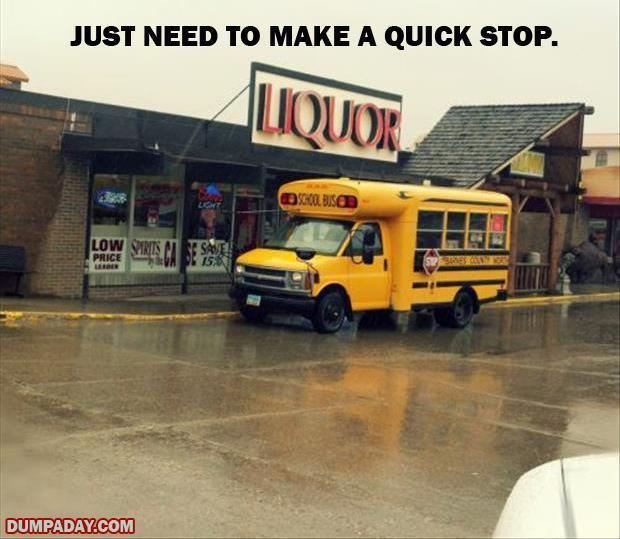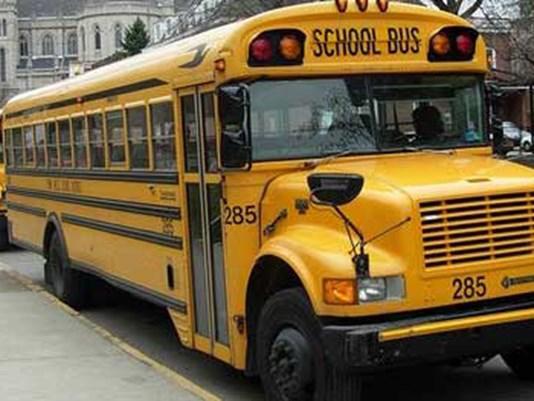The first image is the image on the left, the second image is the image on the right. For the images shown, is this caption "The buses on the left and right both face forward and angle slightly rightward, and people stand in front of the open door of at least one bus." true? Answer yes or no. No. 